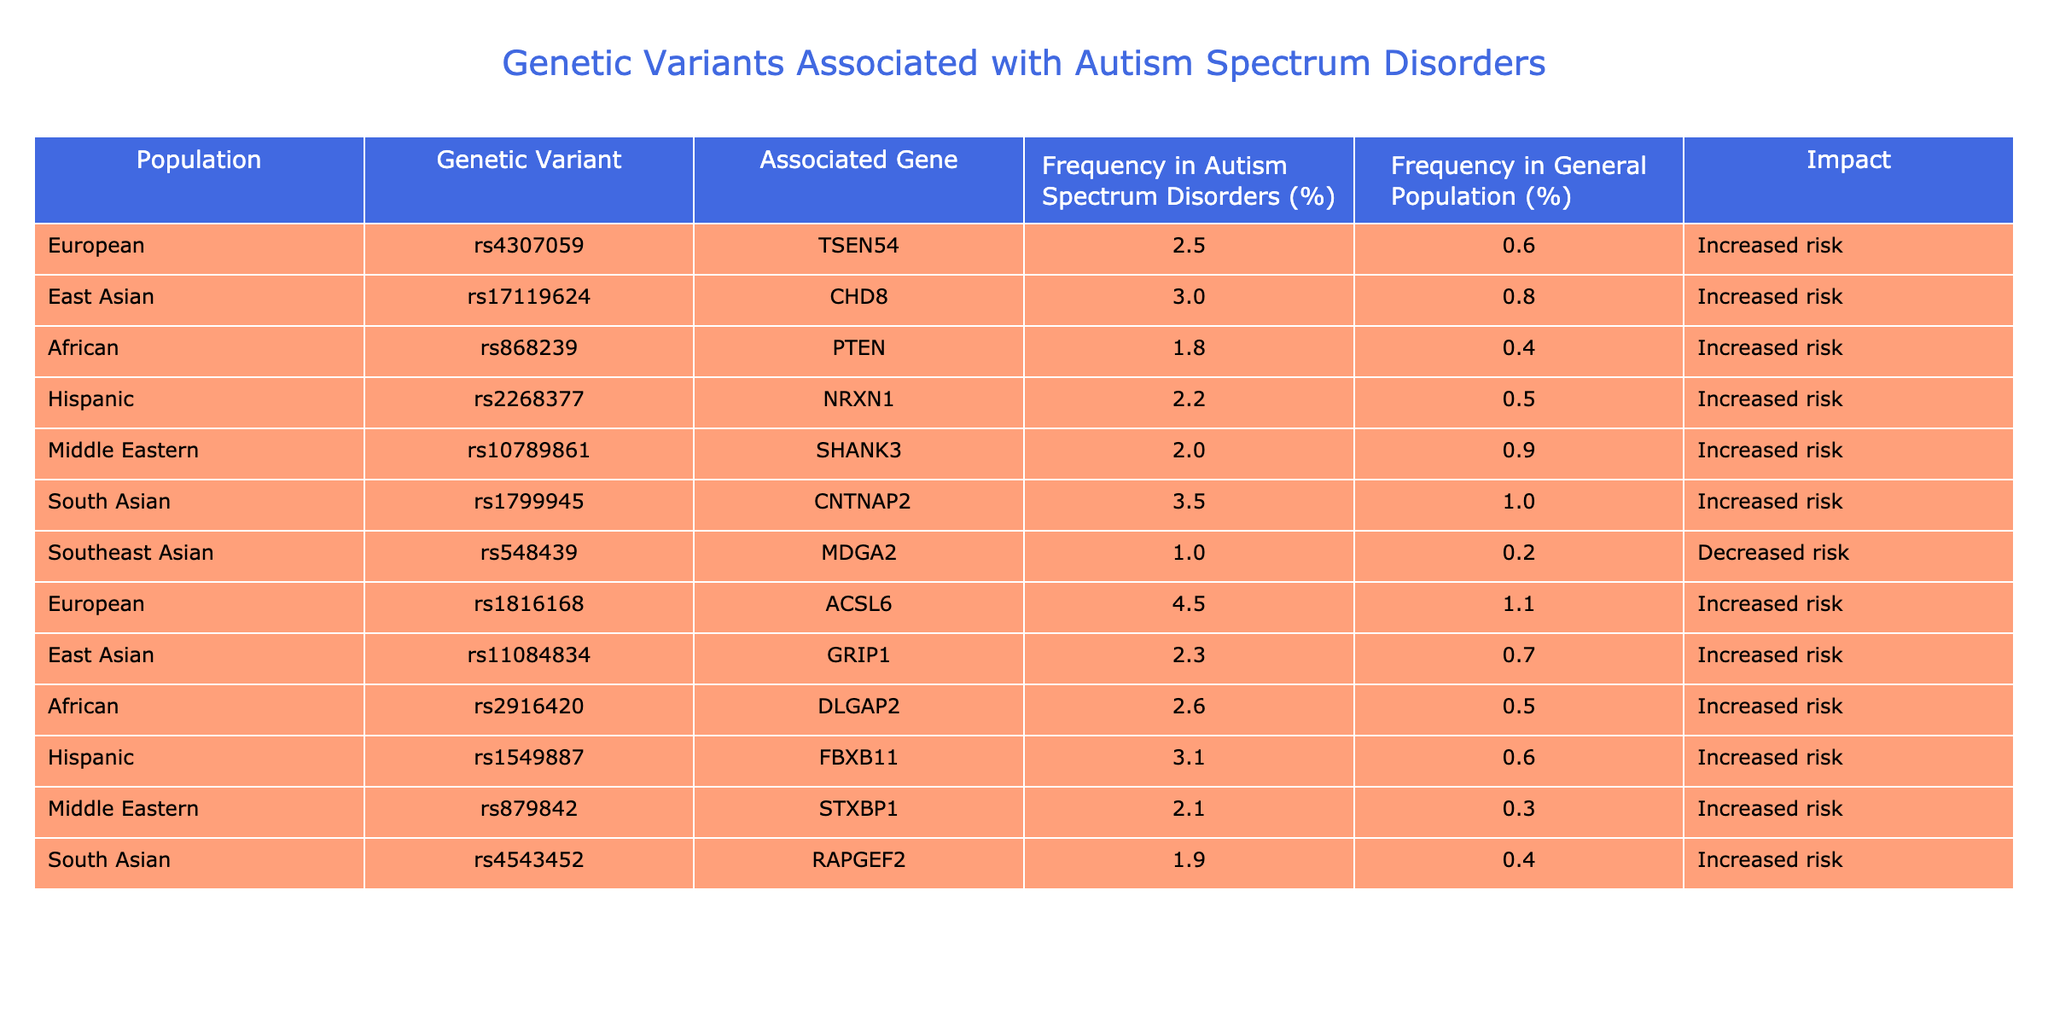What is the frequency of the genetic variant rs1799945 in South Asian populations with autism spectrum disorders? In the table, under the "South Asian" population, the frequency for the genetic variant rs1799945 is listed as 3.5% for autism spectrum disorders.
Answer: 3.5% Which genetic variant has the highest frequency in autism spectrum disorders among the European population? The table shows that the genetic variant rs1816168 has the highest frequency of 4.5% in autism spectrum disorders among the European population.
Answer: rs1816168 What is the difference in frequency for the variant rs868239 between autism spectrum disorders and the general population in African populations? For the genetic variant rs868239, the frequency in autism spectrum disorders is 1.8% and in the general population it is 0.4%. The difference is calculated as 1.8% - 0.4% = 1.4%.
Answer: 1.4% Is the genetic variant rs548439 associated with an increased or decreased risk for autism spectrum disorders in Southeast Asian populations? The table indicates that rs548439 is associated with a decreased risk because it shows a frequency of 1.0% in autism spectrum disorders and 0.2% in the general population, marked as "Decreased risk."
Answer: Decreased risk Which population has the lowest frequency of variants associated with an increased risk for autism spectrum disorders? Looking through the frequencies in the table, the African population has the lowest frequency variant (rs868239) at 1.8% associated with increased risk for autism spectrum disorders.
Answer: African What is the average frequency of genetic variants associated with autism spectrum disorders across all listed populations? To find the average frequency, sum the frequencies (2.5 + 3.0 + 1.8 + 2.2 + 2.0 + 3.5 + 1.0 + 4.5 + 2.3 + 2.6 + 3.1 + 2.1 + 1.9) which totals to 27.0. There are 13 populations, so the average frequency is 27.0 / 13 = 2.08%.
Answer: 2.08% How many genetic variants are associated with an increased risk across all populations listed in the table? By examining the "Impact" column, all the listed variants except for rs548439 are associated with "Increased risk." There are 12 variants associated with increased risk.
Answer: 12 Is there any genetic variant that has the same frequency in both the autism spectrum disorders and general population for any population? Comparing the frequencies, none of the genetic variants listed show the same frequency for both autism spectrum disorders and the general population, indicating that the answer is no.
Answer: No 